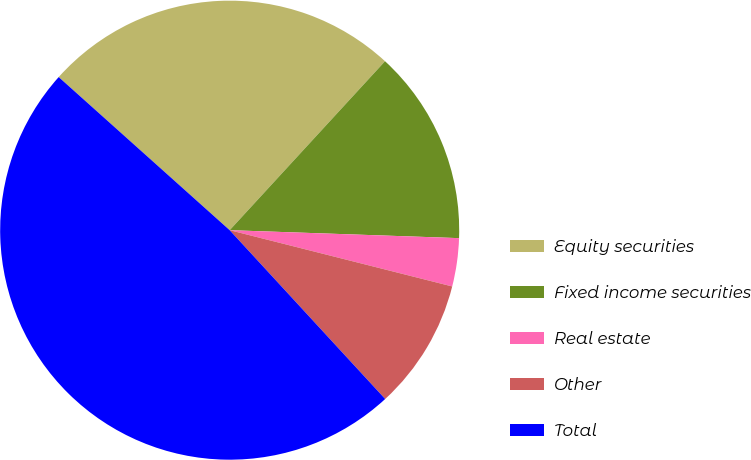<chart> <loc_0><loc_0><loc_500><loc_500><pie_chart><fcel>Equity securities<fcel>Fixed income securities<fcel>Real estate<fcel>Other<fcel>Total<nl><fcel>25.21%<fcel>13.72%<fcel>3.39%<fcel>9.21%<fcel>48.47%<nl></chart> 